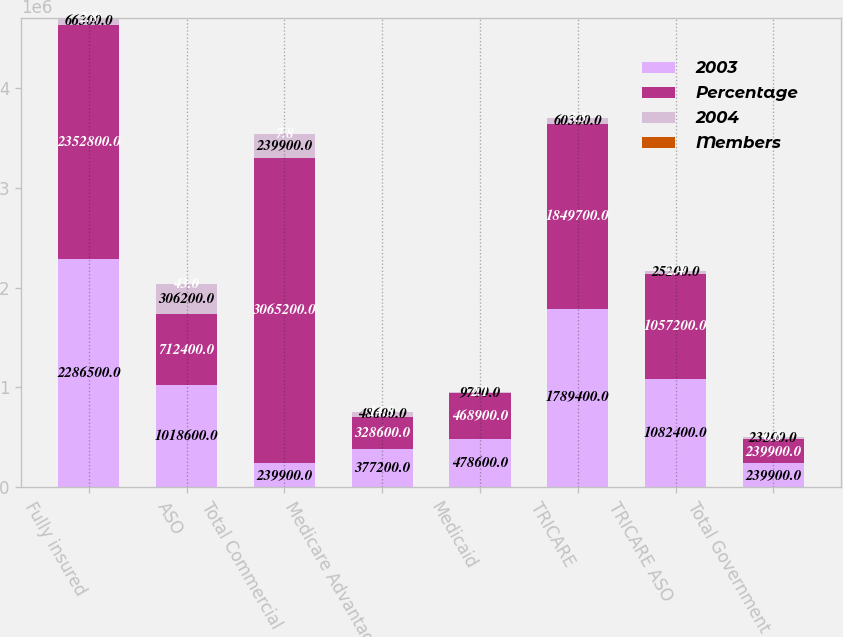Convert chart to OTSL. <chart><loc_0><loc_0><loc_500><loc_500><stacked_bar_chart><ecel><fcel>Fully insured<fcel>ASO<fcel>Total Commercial<fcel>Medicare Advantage<fcel>Medicaid<fcel>TRICARE<fcel>TRICARE ASO<fcel>Total Government<nl><fcel>2003<fcel>2.2865e+06<fcel>1.0186e+06<fcel>239900<fcel>377200<fcel>478600<fcel>1.7894e+06<fcel>1.0824e+06<fcel>239900<nl><fcel>Percentage<fcel>2.3528e+06<fcel>712400<fcel>3.0652e+06<fcel>328600<fcel>468900<fcel>1.8497e+06<fcel>1.0572e+06<fcel>239900<nl><fcel>2004<fcel>66300<fcel>306200<fcel>239900<fcel>48600<fcel>9700<fcel>60300<fcel>25200<fcel>23200<nl><fcel>Members<fcel>2.8<fcel>43<fcel>7.8<fcel>14.8<fcel>2.1<fcel>3.3<fcel>2.4<fcel>0.6<nl></chart> 